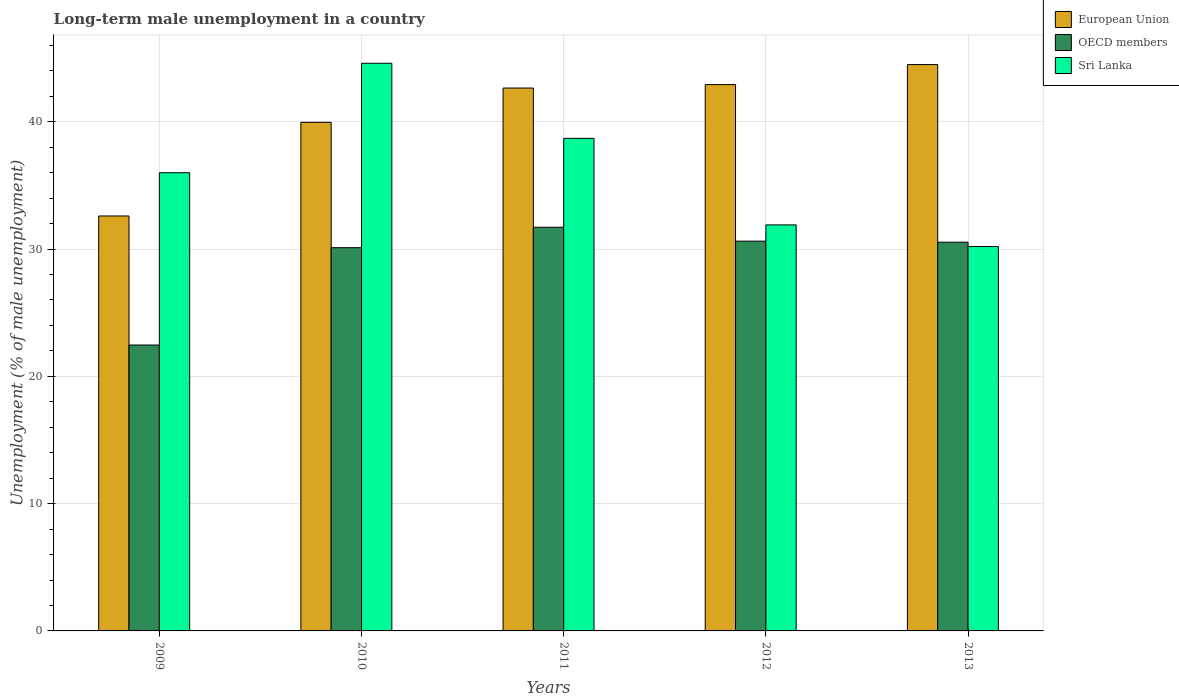Are the number of bars on each tick of the X-axis equal?
Give a very brief answer. Yes. How many bars are there on the 2nd tick from the left?
Offer a terse response. 3. In how many cases, is the number of bars for a given year not equal to the number of legend labels?
Your answer should be very brief. 0. What is the percentage of long-term unemployed male population in Sri Lanka in 2011?
Your response must be concise. 38.7. Across all years, what is the maximum percentage of long-term unemployed male population in Sri Lanka?
Provide a succinct answer. 44.6. Across all years, what is the minimum percentage of long-term unemployed male population in Sri Lanka?
Provide a short and direct response. 30.2. In which year was the percentage of long-term unemployed male population in European Union maximum?
Your answer should be very brief. 2013. In which year was the percentage of long-term unemployed male population in European Union minimum?
Make the answer very short. 2009. What is the total percentage of long-term unemployed male population in OECD members in the graph?
Your response must be concise. 145.45. What is the difference between the percentage of long-term unemployed male population in Sri Lanka in 2011 and that in 2012?
Make the answer very short. 6.8. What is the difference between the percentage of long-term unemployed male population in OECD members in 2010 and the percentage of long-term unemployed male population in Sri Lanka in 2013?
Keep it short and to the point. -0.09. What is the average percentage of long-term unemployed male population in European Union per year?
Offer a terse response. 40.53. In the year 2009, what is the difference between the percentage of long-term unemployed male population in OECD members and percentage of long-term unemployed male population in European Union?
Keep it short and to the point. -10.14. What is the ratio of the percentage of long-term unemployed male population in Sri Lanka in 2009 to that in 2011?
Your answer should be compact. 0.93. Is the percentage of long-term unemployed male population in OECD members in 2012 less than that in 2013?
Keep it short and to the point. No. Is the difference between the percentage of long-term unemployed male population in OECD members in 2011 and 2012 greater than the difference between the percentage of long-term unemployed male population in European Union in 2011 and 2012?
Your answer should be compact. Yes. What is the difference between the highest and the second highest percentage of long-term unemployed male population in Sri Lanka?
Offer a very short reply. 5.9. What is the difference between the highest and the lowest percentage of long-term unemployed male population in European Union?
Offer a terse response. 11.89. In how many years, is the percentage of long-term unemployed male population in Sri Lanka greater than the average percentage of long-term unemployed male population in Sri Lanka taken over all years?
Your response must be concise. 2. What does the 3rd bar from the left in 2011 represents?
Provide a short and direct response. Sri Lanka. Is it the case that in every year, the sum of the percentage of long-term unemployed male population in European Union and percentage of long-term unemployed male population in Sri Lanka is greater than the percentage of long-term unemployed male population in OECD members?
Keep it short and to the point. Yes. How many bars are there?
Your answer should be very brief. 15. Are all the bars in the graph horizontal?
Provide a short and direct response. No. How many years are there in the graph?
Provide a short and direct response. 5. What is the difference between two consecutive major ticks on the Y-axis?
Your answer should be very brief. 10. Are the values on the major ticks of Y-axis written in scientific E-notation?
Ensure brevity in your answer.  No. Does the graph contain grids?
Offer a terse response. Yes. Where does the legend appear in the graph?
Your answer should be very brief. Top right. What is the title of the graph?
Make the answer very short. Long-term male unemployment in a country. What is the label or title of the Y-axis?
Offer a very short reply. Unemployment (% of male unemployment). What is the Unemployment (% of male unemployment) of European Union in 2009?
Provide a succinct answer. 32.6. What is the Unemployment (% of male unemployment) of OECD members in 2009?
Keep it short and to the point. 22.46. What is the Unemployment (% of male unemployment) of Sri Lanka in 2009?
Offer a terse response. 36. What is the Unemployment (% of male unemployment) of European Union in 2010?
Your response must be concise. 39.96. What is the Unemployment (% of male unemployment) in OECD members in 2010?
Your answer should be very brief. 30.11. What is the Unemployment (% of male unemployment) of Sri Lanka in 2010?
Make the answer very short. 44.6. What is the Unemployment (% of male unemployment) of European Union in 2011?
Provide a succinct answer. 42.65. What is the Unemployment (% of male unemployment) in OECD members in 2011?
Make the answer very short. 31.72. What is the Unemployment (% of male unemployment) of Sri Lanka in 2011?
Give a very brief answer. 38.7. What is the Unemployment (% of male unemployment) of European Union in 2012?
Offer a terse response. 42.92. What is the Unemployment (% of male unemployment) in OECD members in 2012?
Keep it short and to the point. 30.62. What is the Unemployment (% of male unemployment) in Sri Lanka in 2012?
Give a very brief answer. 31.9. What is the Unemployment (% of male unemployment) of European Union in 2013?
Provide a succinct answer. 44.5. What is the Unemployment (% of male unemployment) of OECD members in 2013?
Ensure brevity in your answer.  30.54. What is the Unemployment (% of male unemployment) in Sri Lanka in 2013?
Provide a succinct answer. 30.2. Across all years, what is the maximum Unemployment (% of male unemployment) in European Union?
Your answer should be compact. 44.5. Across all years, what is the maximum Unemployment (% of male unemployment) of OECD members?
Your answer should be compact. 31.72. Across all years, what is the maximum Unemployment (% of male unemployment) in Sri Lanka?
Provide a succinct answer. 44.6. Across all years, what is the minimum Unemployment (% of male unemployment) in European Union?
Your response must be concise. 32.6. Across all years, what is the minimum Unemployment (% of male unemployment) in OECD members?
Give a very brief answer. 22.46. Across all years, what is the minimum Unemployment (% of male unemployment) of Sri Lanka?
Ensure brevity in your answer.  30.2. What is the total Unemployment (% of male unemployment) of European Union in the graph?
Give a very brief answer. 202.64. What is the total Unemployment (% of male unemployment) in OECD members in the graph?
Make the answer very short. 145.45. What is the total Unemployment (% of male unemployment) in Sri Lanka in the graph?
Your answer should be very brief. 181.4. What is the difference between the Unemployment (% of male unemployment) in European Union in 2009 and that in 2010?
Make the answer very short. -7.36. What is the difference between the Unemployment (% of male unemployment) of OECD members in 2009 and that in 2010?
Offer a very short reply. -7.65. What is the difference between the Unemployment (% of male unemployment) of Sri Lanka in 2009 and that in 2010?
Your answer should be very brief. -8.6. What is the difference between the Unemployment (% of male unemployment) of European Union in 2009 and that in 2011?
Provide a short and direct response. -10.05. What is the difference between the Unemployment (% of male unemployment) in OECD members in 2009 and that in 2011?
Your answer should be very brief. -9.25. What is the difference between the Unemployment (% of male unemployment) in Sri Lanka in 2009 and that in 2011?
Ensure brevity in your answer.  -2.7. What is the difference between the Unemployment (% of male unemployment) in European Union in 2009 and that in 2012?
Keep it short and to the point. -10.32. What is the difference between the Unemployment (% of male unemployment) in OECD members in 2009 and that in 2012?
Offer a very short reply. -8.16. What is the difference between the Unemployment (% of male unemployment) of European Union in 2009 and that in 2013?
Offer a terse response. -11.89. What is the difference between the Unemployment (% of male unemployment) of OECD members in 2009 and that in 2013?
Your answer should be compact. -8.08. What is the difference between the Unemployment (% of male unemployment) in Sri Lanka in 2009 and that in 2013?
Give a very brief answer. 5.8. What is the difference between the Unemployment (% of male unemployment) in European Union in 2010 and that in 2011?
Ensure brevity in your answer.  -2.69. What is the difference between the Unemployment (% of male unemployment) in OECD members in 2010 and that in 2011?
Your response must be concise. -1.61. What is the difference between the Unemployment (% of male unemployment) in Sri Lanka in 2010 and that in 2011?
Ensure brevity in your answer.  5.9. What is the difference between the Unemployment (% of male unemployment) of European Union in 2010 and that in 2012?
Offer a terse response. -2.96. What is the difference between the Unemployment (% of male unemployment) of OECD members in 2010 and that in 2012?
Provide a short and direct response. -0.51. What is the difference between the Unemployment (% of male unemployment) in Sri Lanka in 2010 and that in 2012?
Your answer should be very brief. 12.7. What is the difference between the Unemployment (% of male unemployment) of European Union in 2010 and that in 2013?
Provide a short and direct response. -4.54. What is the difference between the Unemployment (% of male unemployment) of OECD members in 2010 and that in 2013?
Make the answer very short. -0.43. What is the difference between the Unemployment (% of male unemployment) in Sri Lanka in 2010 and that in 2013?
Ensure brevity in your answer.  14.4. What is the difference between the Unemployment (% of male unemployment) in European Union in 2011 and that in 2012?
Your answer should be very brief. -0.27. What is the difference between the Unemployment (% of male unemployment) in OECD members in 2011 and that in 2012?
Your response must be concise. 1.09. What is the difference between the Unemployment (% of male unemployment) in European Union in 2011 and that in 2013?
Your response must be concise. -1.84. What is the difference between the Unemployment (% of male unemployment) of OECD members in 2011 and that in 2013?
Offer a terse response. 1.18. What is the difference between the Unemployment (% of male unemployment) in European Union in 2012 and that in 2013?
Your response must be concise. -1.57. What is the difference between the Unemployment (% of male unemployment) of OECD members in 2012 and that in 2013?
Make the answer very short. 0.08. What is the difference between the Unemployment (% of male unemployment) in Sri Lanka in 2012 and that in 2013?
Provide a succinct answer. 1.7. What is the difference between the Unemployment (% of male unemployment) of European Union in 2009 and the Unemployment (% of male unemployment) of OECD members in 2010?
Make the answer very short. 2.49. What is the difference between the Unemployment (% of male unemployment) in European Union in 2009 and the Unemployment (% of male unemployment) in Sri Lanka in 2010?
Give a very brief answer. -12. What is the difference between the Unemployment (% of male unemployment) in OECD members in 2009 and the Unemployment (% of male unemployment) in Sri Lanka in 2010?
Provide a succinct answer. -22.14. What is the difference between the Unemployment (% of male unemployment) of European Union in 2009 and the Unemployment (% of male unemployment) of OECD members in 2011?
Your answer should be compact. 0.89. What is the difference between the Unemployment (% of male unemployment) of European Union in 2009 and the Unemployment (% of male unemployment) of Sri Lanka in 2011?
Your response must be concise. -6.1. What is the difference between the Unemployment (% of male unemployment) in OECD members in 2009 and the Unemployment (% of male unemployment) in Sri Lanka in 2011?
Give a very brief answer. -16.24. What is the difference between the Unemployment (% of male unemployment) of European Union in 2009 and the Unemployment (% of male unemployment) of OECD members in 2012?
Provide a succinct answer. 1.98. What is the difference between the Unemployment (% of male unemployment) in European Union in 2009 and the Unemployment (% of male unemployment) in Sri Lanka in 2012?
Provide a succinct answer. 0.7. What is the difference between the Unemployment (% of male unemployment) in OECD members in 2009 and the Unemployment (% of male unemployment) in Sri Lanka in 2012?
Give a very brief answer. -9.44. What is the difference between the Unemployment (% of male unemployment) of European Union in 2009 and the Unemployment (% of male unemployment) of OECD members in 2013?
Offer a very short reply. 2.06. What is the difference between the Unemployment (% of male unemployment) in European Union in 2009 and the Unemployment (% of male unemployment) in Sri Lanka in 2013?
Make the answer very short. 2.4. What is the difference between the Unemployment (% of male unemployment) of OECD members in 2009 and the Unemployment (% of male unemployment) of Sri Lanka in 2013?
Your answer should be compact. -7.74. What is the difference between the Unemployment (% of male unemployment) of European Union in 2010 and the Unemployment (% of male unemployment) of OECD members in 2011?
Your answer should be compact. 8.25. What is the difference between the Unemployment (% of male unemployment) in European Union in 2010 and the Unemployment (% of male unemployment) in Sri Lanka in 2011?
Offer a terse response. 1.26. What is the difference between the Unemployment (% of male unemployment) in OECD members in 2010 and the Unemployment (% of male unemployment) in Sri Lanka in 2011?
Your response must be concise. -8.59. What is the difference between the Unemployment (% of male unemployment) in European Union in 2010 and the Unemployment (% of male unemployment) in OECD members in 2012?
Provide a succinct answer. 9.34. What is the difference between the Unemployment (% of male unemployment) of European Union in 2010 and the Unemployment (% of male unemployment) of Sri Lanka in 2012?
Provide a succinct answer. 8.06. What is the difference between the Unemployment (% of male unemployment) in OECD members in 2010 and the Unemployment (% of male unemployment) in Sri Lanka in 2012?
Offer a terse response. -1.79. What is the difference between the Unemployment (% of male unemployment) of European Union in 2010 and the Unemployment (% of male unemployment) of OECD members in 2013?
Your response must be concise. 9.42. What is the difference between the Unemployment (% of male unemployment) of European Union in 2010 and the Unemployment (% of male unemployment) of Sri Lanka in 2013?
Your answer should be very brief. 9.76. What is the difference between the Unemployment (% of male unemployment) of OECD members in 2010 and the Unemployment (% of male unemployment) of Sri Lanka in 2013?
Offer a terse response. -0.09. What is the difference between the Unemployment (% of male unemployment) in European Union in 2011 and the Unemployment (% of male unemployment) in OECD members in 2012?
Ensure brevity in your answer.  12.03. What is the difference between the Unemployment (% of male unemployment) of European Union in 2011 and the Unemployment (% of male unemployment) of Sri Lanka in 2012?
Provide a succinct answer. 10.75. What is the difference between the Unemployment (% of male unemployment) of OECD members in 2011 and the Unemployment (% of male unemployment) of Sri Lanka in 2012?
Ensure brevity in your answer.  -0.18. What is the difference between the Unemployment (% of male unemployment) in European Union in 2011 and the Unemployment (% of male unemployment) in OECD members in 2013?
Your answer should be very brief. 12.11. What is the difference between the Unemployment (% of male unemployment) in European Union in 2011 and the Unemployment (% of male unemployment) in Sri Lanka in 2013?
Provide a short and direct response. 12.45. What is the difference between the Unemployment (% of male unemployment) of OECD members in 2011 and the Unemployment (% of male unemployment) of Sri Lanka in 2013?
Ensure brevity in your answer.  1.52. What is the difference between the Unemployment (% of male unemployment) of European Union in 2012 and the Unemployment (% of male unemployment) of OECD members in 2013?
Make the answer very short. 12.38. What is the difference between the Unemployment (% of male unemployment) in European Union in 2012 and the Unemployment (% of male unemployment) in Sri Lanka in 2013?
Offer a very short reply. 12.72. What is the difference between the Unemployment (% of male unemployment) in OECD members in 2012 and the Unemployment (% of male unemployment) in Sri Lanka in 2013?
Offer a very short reply. 0.42. What is the average Unemployment (% of male unemployment) of European Union per year?
Offer a very short reply. 40.53. What is the average Unemployment (% of male unemployment) in OECD members per year?
Offer a very short reply. 29.09. What is the average Unemployment (% of male unemployment) in Sri Lanka per year?
Give a very brief answer. 36.28. In the year 2009, what is the difference between the Unemployment (% of male unemployment) in European Union and Unemployment (% of male unemployment) in OECD members?
Provide a succinct answer. 10.14. In the year 2009, what is the difference between the Unemployment (% of male unemployment) of European Union and Unemployment (% of male unemployment) of Sri Lanka?
Provide a short and direct response. -3.4. In the year 2009, what is the difference between the Unemployment (% of male unemployment) in OECD members and Unemployment (% of male unemployment) in Sri Lanka?
Ensure brevity in your answer.  -13.54. In the year 2010, what is the difference between the Unemployment (% of male unemployment) in European Union and Unemployment (% of male unemployment) in OECD members?
Make the answer very short. 9.85. In the year 2010, what is the difference between the Unemployment (% of male unemployment) in European Union and Unemployment (% of male unemployment) in Sri Lanka?
Keep it short and to the point. -4.64. In the year 2010, what is the difference between the Unemployment (% of male unemployment) of OECD members and Unemployment (% of male unemployment) of Sri Lanka?
Offer a very short reply. -14.49. In the year 2011, what is the difference between the Unemployment (% of male unemployment) in European Union and Unemployment (% of male unemployment) in OECD members?
Your response must be concise. 10.94. In the year 2011, what is the difference between the Unemployment (% of male unemployment) in European Union and Unemployment (% of male unemployment) in Sri Lanka?
Your answer should be compact. 3.95. In the year 2011, what is the difference between the Unemployment (% of male unemployment) in OECD members and Unemployment (% of male unemployment) in Sri Lanka?
Offer a terse response. -6.98. In the year 2012, what is the difference between the Unemployment (% of male unemployment) in European Union and Unemployment (% of male unemployment) in OECD members?
Provide a short and direct response. 12.3. In the year 2012, what is the difference between the Unemployment (% of male unemployment) of European Union and Unemployment (% of male unemployment) of Sri Lanka?
Offer a terse response. 11.02. In the year 2012, what is the difference between the Unemployment (% of male unemployment) of OECD members and Unemployment (% of male unemployment) of Sri Lanka?
Your answer should be compact. -1.28. In the year 2013, what is the difference between the Unemployment (% of male unemployment) of European Union and Unemployment (% of male unemployment) of OECD members?
Your answer should be very brief. 13.96. In the year 2013, what is the difference between the Unemployment (% of male unemployment) in European Union and Unemployment (% of male unemployment) in Sri Lanka?
Offer a very short reply. 14.3. In the year 2013, what is the difference between the Unemployment (% of male unemployment) of OECD members and Unemployment (% of male unemployment) of Sri Lanka?
Your answer should be very brief. 0.34. What is the ratio of the Unemployment (% of male unemployment) of European Union in 2009 to that in 2010?
Your answer should be compact. 0.82. What is the ratio of the Unemployment (% of male unemployment) of OECD members in 2009 to that in 2010?
Ensure brevity in your answer.  0.75. What is the ratio of the Unemployment (% of male unemployment) of Sri Lanka in 2009 to that in 2010?
Offer a very short reply. 0.81. What is the ratio of the Unemployment (% of male unemployment) in European Union in 2009 to that in 2011?
Give a very brief answer. 0.76. What is the ratio of the Unemployment (% of male unemployment) in OECD members in 2009 to that in 2011?
Provide a short and direct response. 0.71. What is the ratio of the Unemployment (% of male unemployment) of Sri Lanka in 2009 to that in 2011?
Keep it short and to the point. 0.93. What is the ratio of the Unemployment (% of male unemployment) of European Union in 2009 to that in 2012?
Your answer should be compact. 0.76. What is the ratio of the Unemployment (% of male unemployment) in OECD members in 2009 to that in 2012?
Provide a succinct answer. 0.73. What is the ratio of the Unemployment (% of male unemployment) of Sri Lanka in 2009 to that in 2012?
Provide a short and direct response. 1.13. What is the ratio of the Unemployment (% of male unemployment) in European Union in 2009 to that in 2013?
Provide a short and direct response. 0.73. What is the ratio of the Unemployment (% of male unemployment) of OECD members in 2009 to that in 2013?
Ensure brevity in your answer.  0.74. What is the ratio of the Unemployment (% of male unemployment) in Sri Lanka in 2009 to that in 2013?
Keep it short and to the point. 1.19. What is the ratio of the Unemployment (% of male unemployment) of European Union in 2010 to that in 2011?
Keep it short and to the point. 0.94. What is the ratio of the Unemployment (% of male unemployment) of OECD members in 2010 to that in 2011?
Make the answer very short. 0.95. What is the ratio of the Unemployment (% of male unemployment) in Sri Lanka in 2010 to that in 2011?
Provide a succinct answer. 1.15. What is the ratio of the Unemployment (% of male unemployment) of European Union in 2010 to that in 2012?
Provide a succinct answer. 0.93. What is the ratio of the Unemployment (% of male unemployment) of OECD members in 2010 to that in 2012?
Provide a succinct answer. 0.98. What is the ratio of the Unemployment (% of male unemployment) of Sri Lanka in 2010 to that in 2012?
Your response must be concise. 1.4. What is the ratio of the Unemployment (% of male unemployment) in European Union in 2010 to that in 2013?
Your answer should be very brief. 0.9. What is the ratio of the Unemployment (% of male unemployment) in OECD members in 2010 to that in 2013?
Give a very brief answer. 0.99. What is the ratio of the Unemployment (% of male unemployment) of Sri Lanka in 2010 to that in 2013?
Your answer should be compact. 1.48. What is the ratio of the Unemployment (% of male unemployment) of European Union in 2011 to that in 2012?
Make the answer very short. 0.99. What is the ratio of the Unemployment (% of male unemployment) in OECD members in 2011 to that in 2012?
Your answer should be very brief. 1.04. What is the ratio of the Unemployment (% of male unemployment) of Sri Lanka in 2011 to that in 2012?
Offer a terse response. 1.21. What is the ratio of the Unemployment (% of male unemployment) of European Union in 2011 to that in 2013?
Provide a succinct answer. 0.96. What is the ratio of the Unemployment (% of male unemployment) in OECD members in 2011 to that in 2013?
Ensure brevity in your answer.  1.04. What is the ratio of the Unemployment (% of male unemployment) in Sri Lanka in 2011 to that in 2013?
Your answer should be very brief. 1.28. What is the ratio of the Unemployment (% of male unemployment) in European Union in 2012 to that in 2013?
Your answer should be compact. 0.96. What is the ratio of the Unemployment (% of male unemployment) of Sri Lanka in 2012 to that in 2013?
Offer a terse response. 1.06. What is the difference between the highest and the second highest Unemployment (% of male unemployment) of European Union?
Give a very brief answer. 1.57. What is the difference between the highest and the second highest Unemployment (% of male unemployment) of OECD members?
Offer a very short reply. 1.09. What is the difference between the highest and the lowest Unemployment (% of male unemployment) in European Union?
Make the answer very short. 11.89. What is the difference between the highest and the lowest Unemployment (% of male unemployment) of OECD members?
Provide a succinct answer. 9.25. 